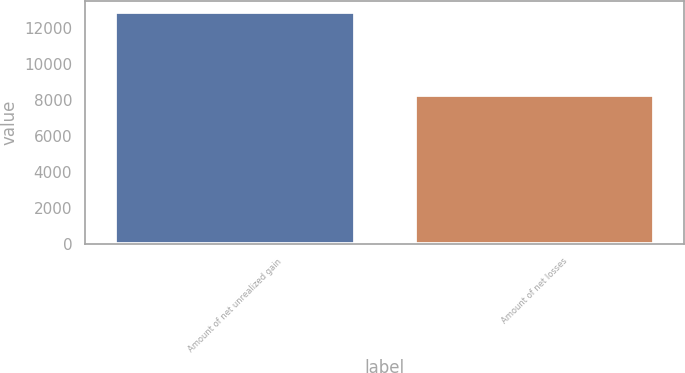Convert chart. <chart><loc_0><loc_0><loc_500><loc_500><bar_chart><fcel>Amount of net unrealized gain<fcel>Amount of net losses<nl><fcel>12859<fcel>8240<nl></chart> 